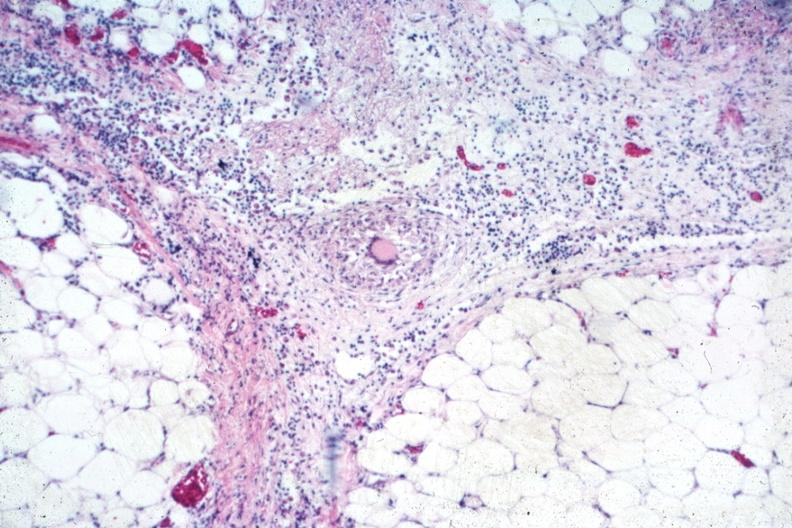s opened abdominal cavity with massive tumor in omentum none apparent in liver nor over peritoneal surfaces gut present?
Answer the question using a single word or phrase. No 